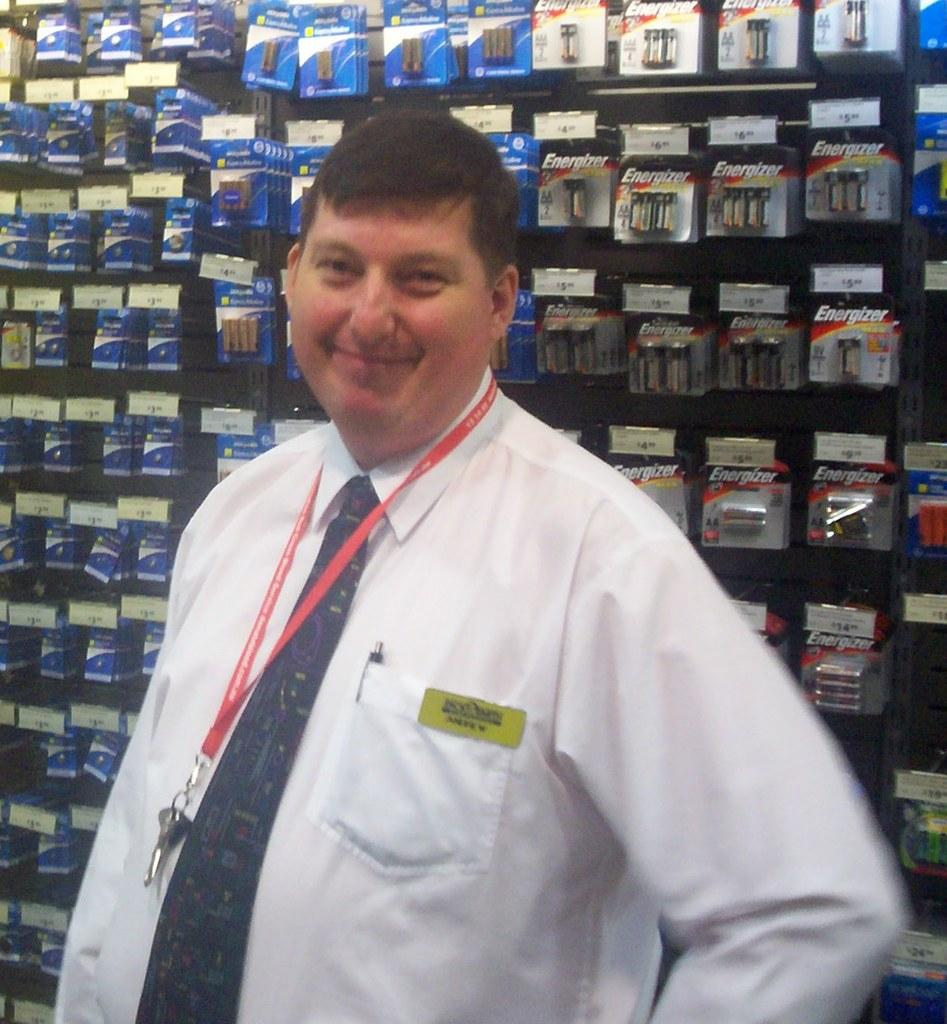<image>
Write a terse but informative summary of the picture. A man with a name badge on his shirt poses for a photo in front of a wall of Energizer and other types of batteries. 